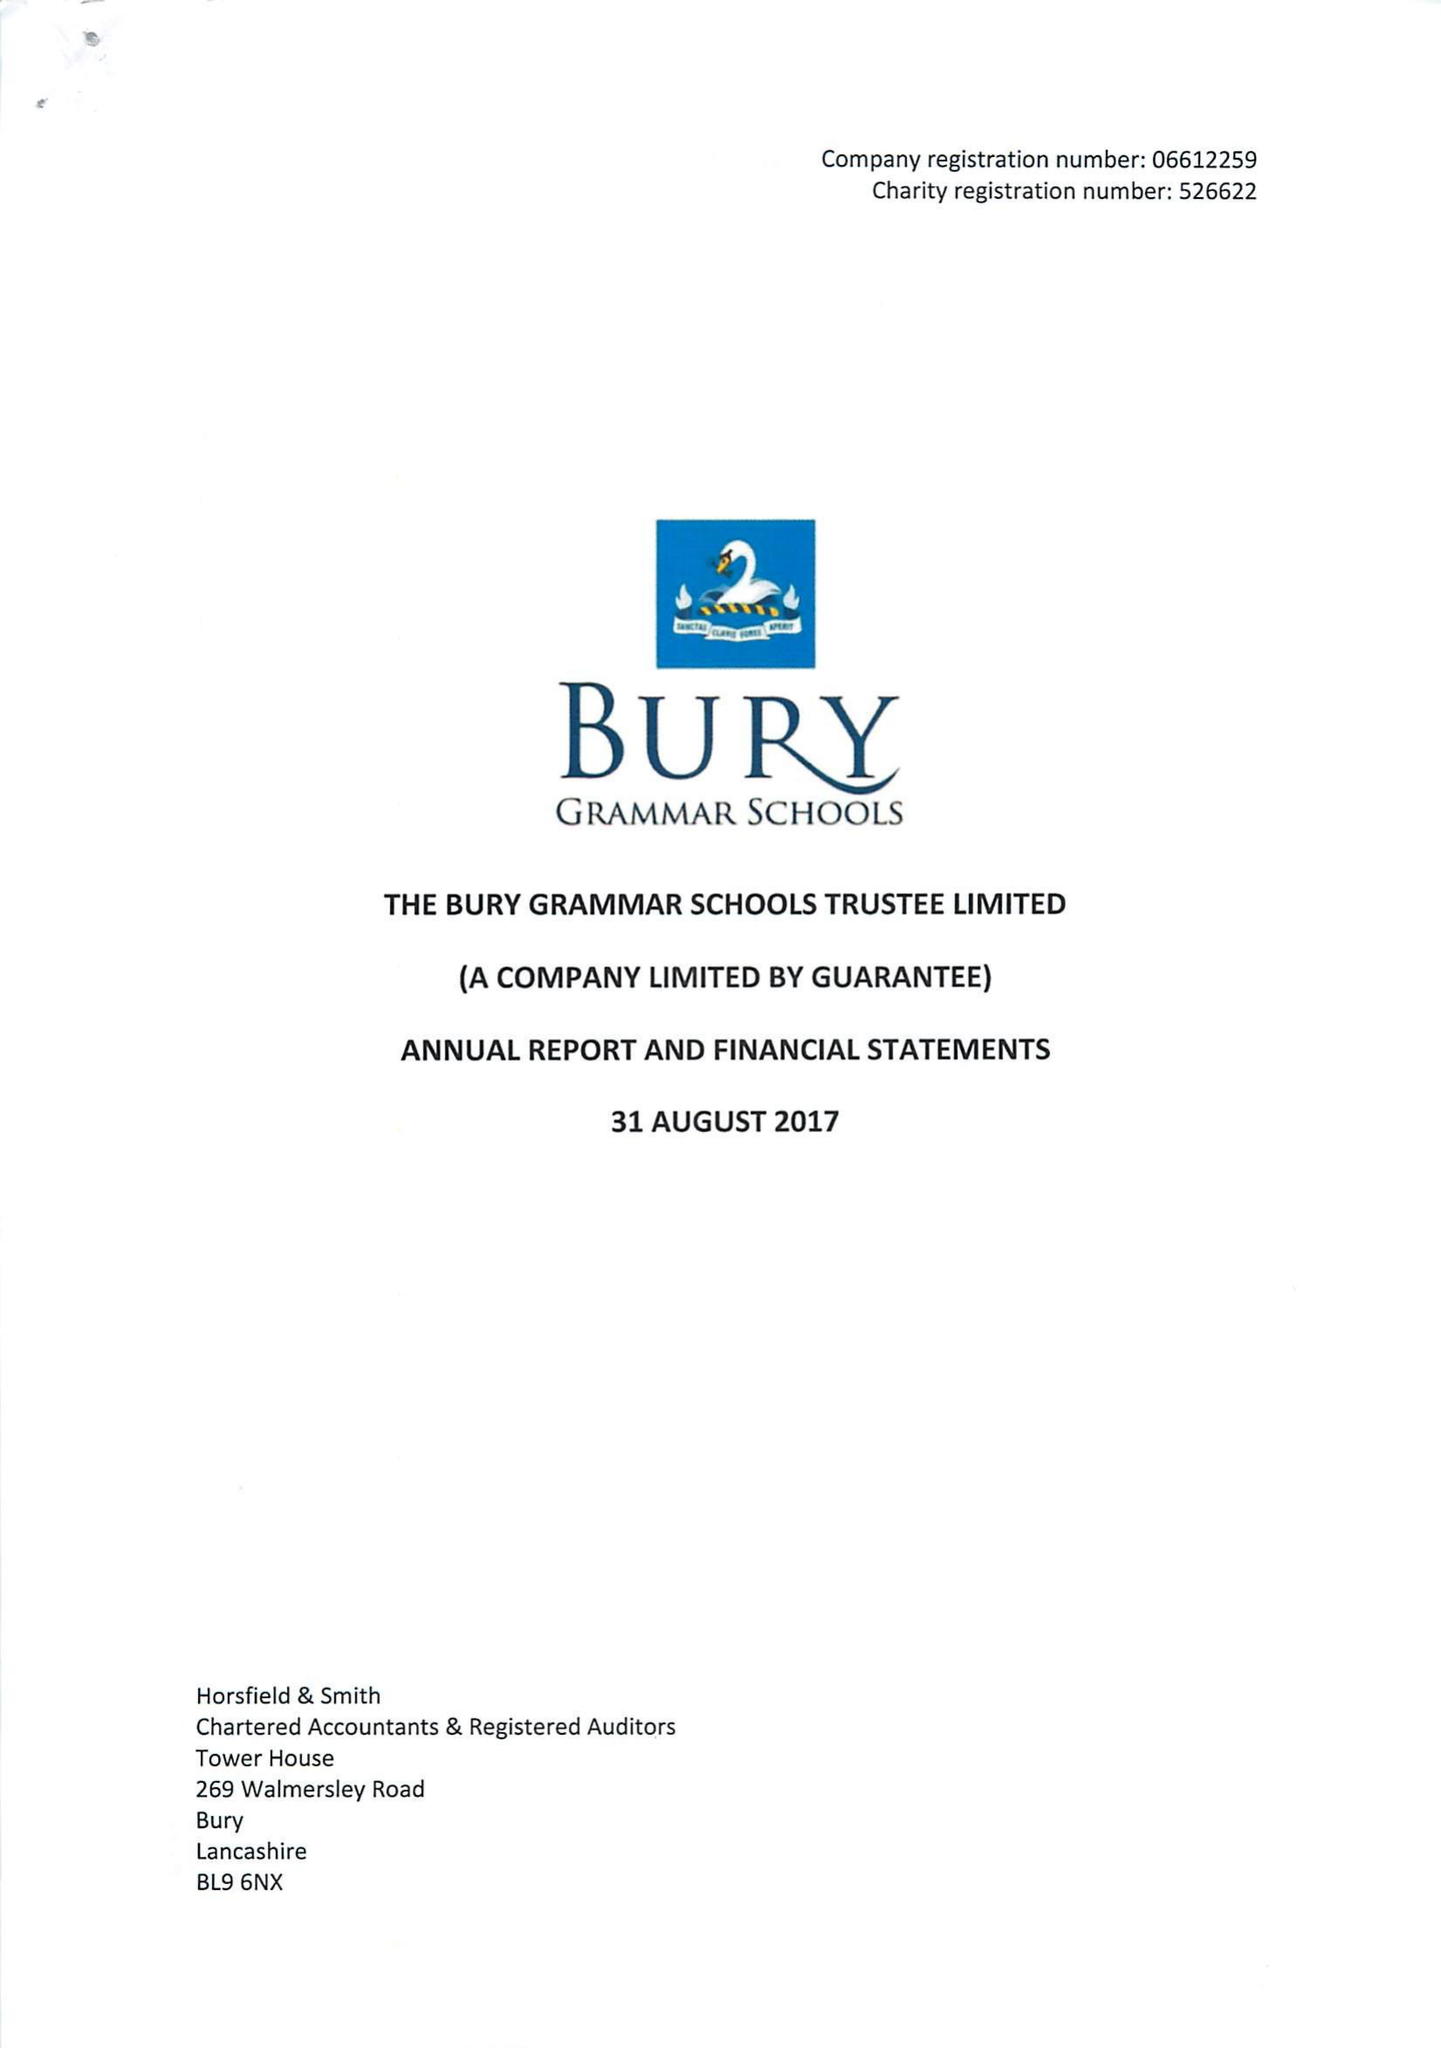What is the value for the address__postcode?
Answer the question using a single word or phrase. BL9 0HG 